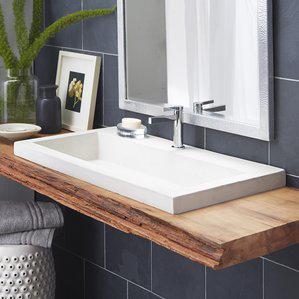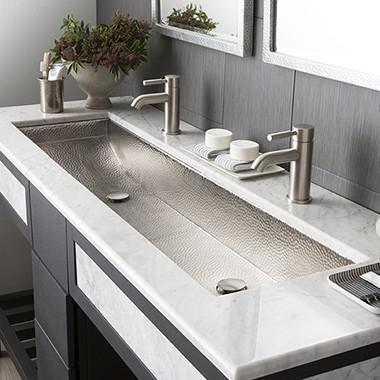The first image is the image on the left, the second image is the image on the right. For the images displayed, is the sentence "Each of the vanity sinks pictured has two faucets." factually correct? Answer yes or no. No. 